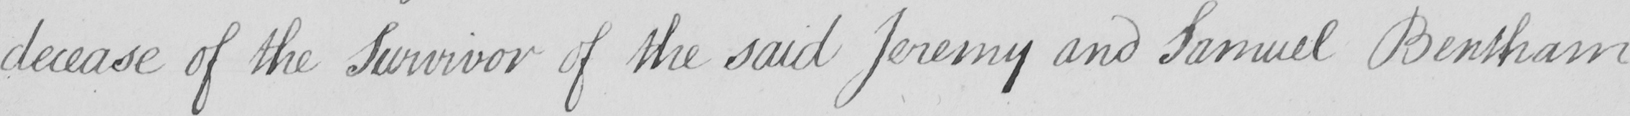Please transcribe the handwritten text in this image. decease of the Survivor of the said Jeremy and Samuel Bentham 